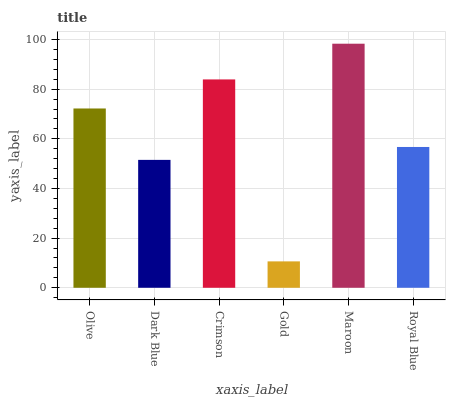Is Gold the minimum?
Answer yes or no. Yes. Is Maroon the maximum?
Answer yes or no. Yes. Is Dark Blue the minimum?
Answer yes or no. No. Is Dark Blue the maximum?
Answer yes or no. No. Is Olive greater than Dark Blue?
Answer yes or no. Yes. Is Dark Blue less than Olive?
Answer yes or no. Yes. Is Dark Blue greater than Olive?
Answer yes or no. No. Is Olive less than Dark Blue?
Answer yes or no. No. Is Olive the high median?
Answer yes or no. Yes. Is Royal Blue the low median?
Answer yes or no. Yes. Is Gold the high median?
Answer yes or no. No. Is Gold the low median?
Answer yes or no. No. 